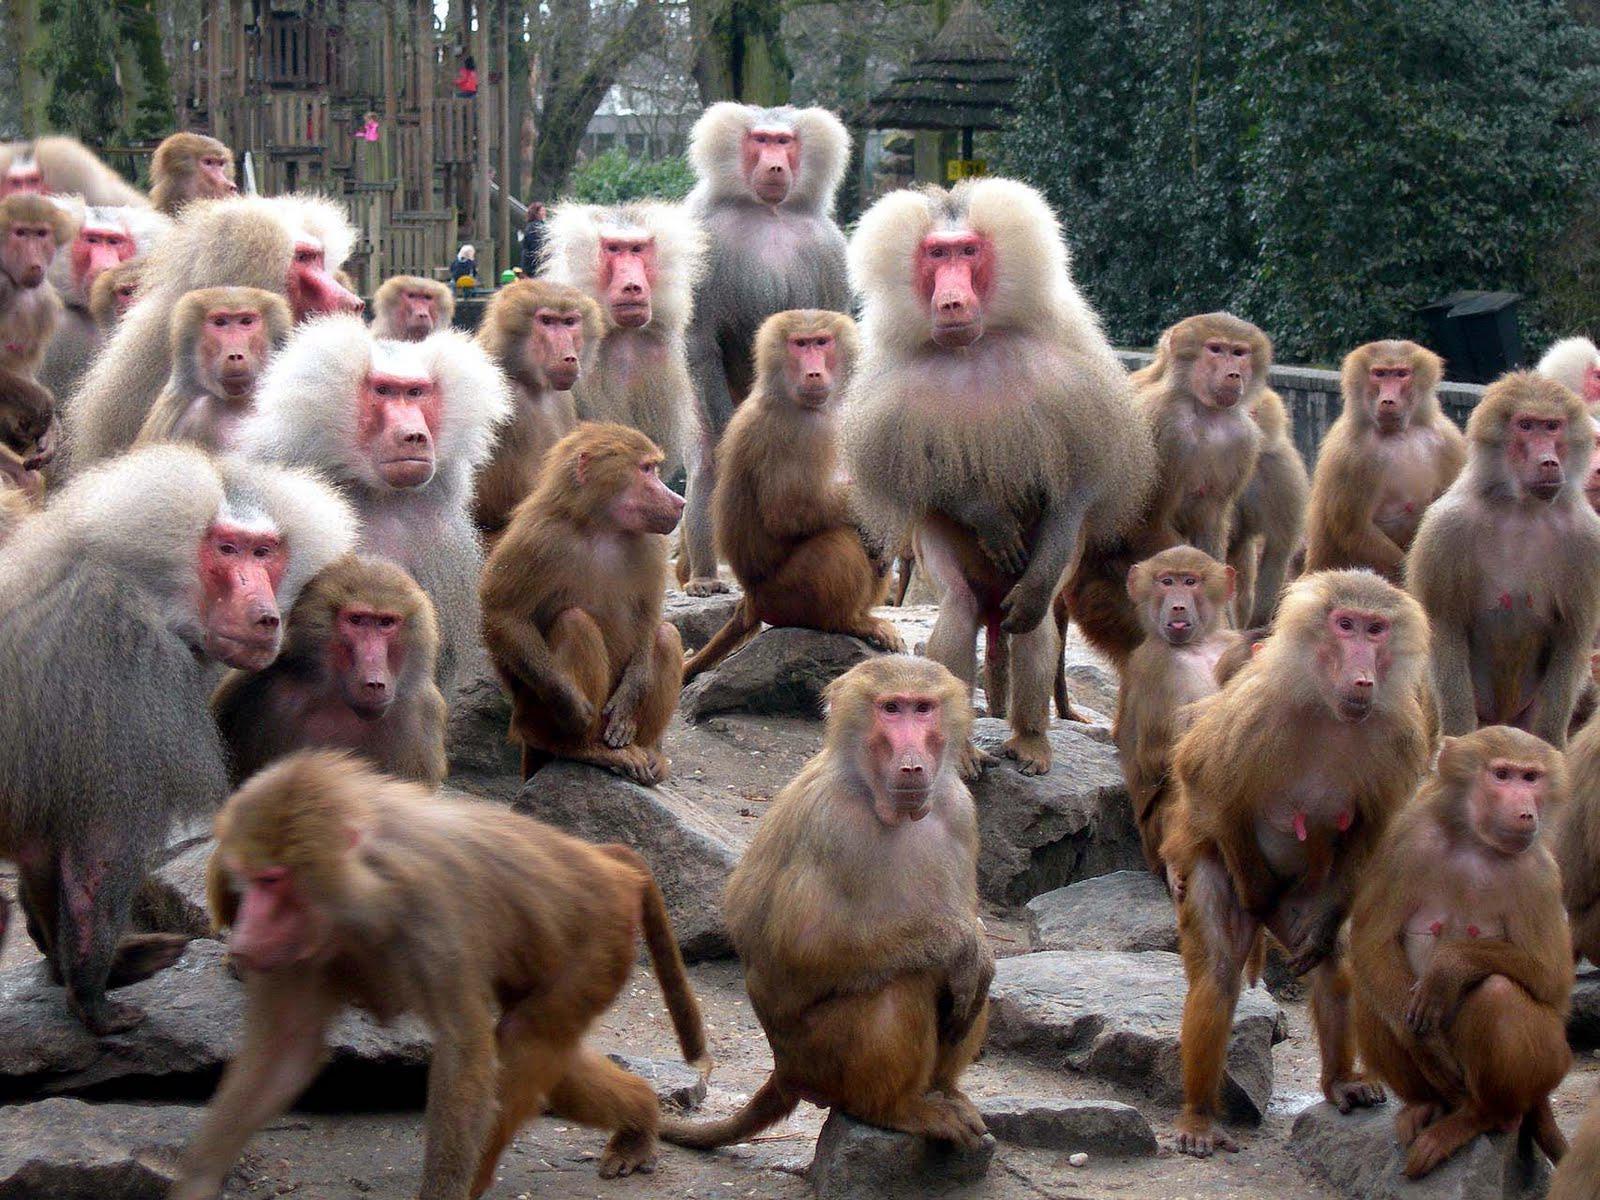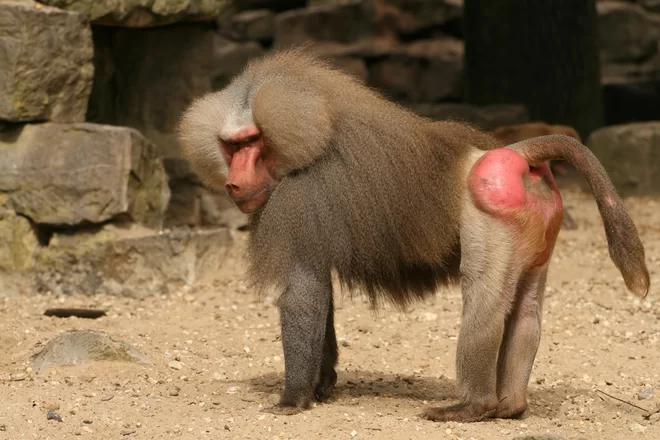The first image is the image on the left, the second image is the image on the right. Assess this claim about the two images: "One image depicts at aleast a dozen baboons posed on a dry surface.". Correct or not? Answer yes or no. Yes. The first image is the image on the left, the second image is the image on the right. Given the left and right images, does the statement "There is a single babboon in one of the images." hold true? Answer yes or no. Yes. The first image is the image on the left, the second image is the image on the right. Analyze the images presented: Is the assertion "An image shows the bulbous pinkish rear of one adult baboon." valid? Answer yes or no. Yes. The first image is the image on the left, the second image is the image on the right. Given the left and right images, does the statement "There is exactly one animal in one of the images." hold true? Answer yes or no. Yes. 